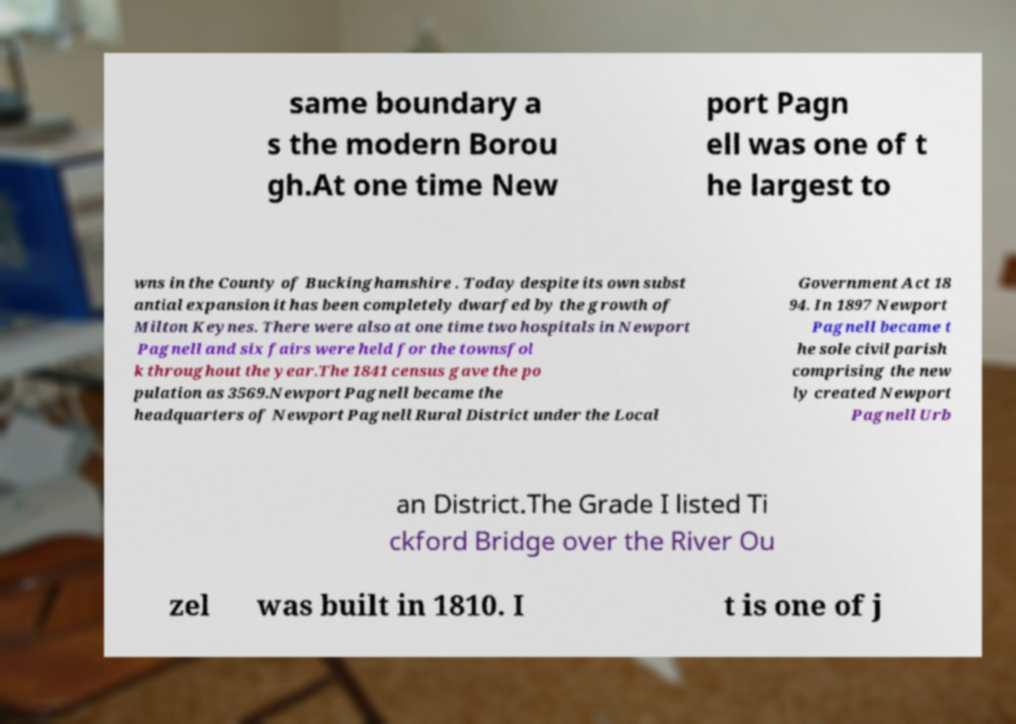I need the written content from this picture converted into text. Can you do that? same boundary a s the modern Borou gh.At one time New port Pagn ell was one of t he largest to wns in the County of Buckinghamshire . Today despite its own subst antial expansion it has been completely dwarfed by the growth of Milton Keynes. There were also at one time two hospitals in Newport Pagnell and six fairs were held for the townsfol k throughout the year.The 1841 census gave the po pulation as 3569.Newport Pagnell became the headquarters of Newport Pagnell Rural District under the Local Government Act 18 94. In 1897 Newport Pagnell became t he sole civil parish comprising the new ly created Newport Pagnell Urb an District.The Grade I listed Ti ckford Bridge over the River Ou zel was built in 1810. I t is one of j 